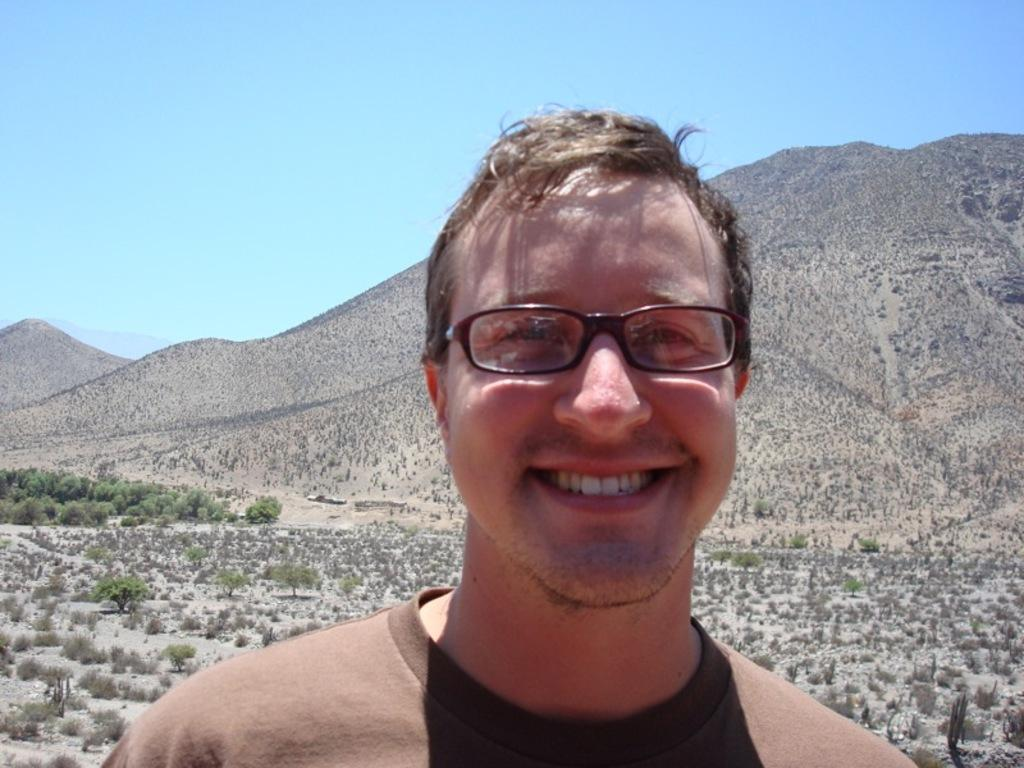What is the main subject of the image? There is a person in the image. What is the person wearing? The person is wearing a brown color T-shirt. Can you describe any accessories the person is wearing? The person is wearing spectacles. What is the person's facial expression? The person is smiling. What can be seen in the background of the image? There are trees, hills, and a blue sky in the background of the image. What type of quartz can be seen in the person's hand in the image? There is no quartz present in the image; the person is not holding any quartz. Can you describe the person's attempt to climb the hill in the background? There is no attempt to climb the hill shown in the image; the person is not depicted as engaging in any physical activity. 